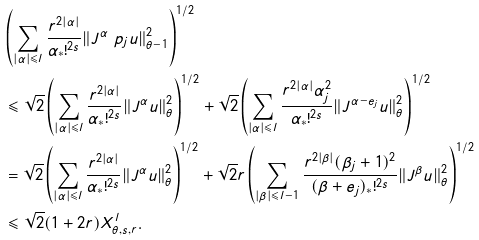<formula> <loc_0><loc_0><loc_500><loc_500>& \left ( \sum _ { | \alpha | \leqslant { l } } \frac { r ^ { 2 | \alpha | } } { \alpha _ { \ast } ! ^ { 2 s } } \| { J ^ { \alpha } \ p _ { j } u } \| _ { \theta - 1 } ^ { 2 } \right ) ^ { 1 / 2 } \\ & \leqslant \sqrt { 2 } \left ( \sum _ { | \alpha | \leqslant { l } } \frac { r ^ { 2 | \alpha | } } { \alpha _ { \ast } ! ^ { 2 s } } \| { J ^ { \alpha } } u \| _ { \theta } ^ { 2 } \right ) ^ { 1 / 2 } + \sqrt { 2 } \left ( \sum _ { | \alpha | \leqslant { l } } \frac { r ^ { 2 | \alpha | } \alpha _ { j } ^ { 2 } } { \alpha _ { \ast } ! ^ { 2 s } } \| { J ^ { \alpha - e _ { j } } u } \| _ { \theta } ^ { 2 } \right ) ^ { 1 / 2 } \\ & = \sqrt { 2 } \left ( \sum _ { | \alpha | \leqslant { l } } \frac { r ^ { 2 | \alpha | } } { \alpha _ { \ast } ! ^ { 2 s } } \| { J ^ { \alpha } } u \| _ { \theta } ^ { 2 } \right ) ^ { 1 / 2 } + \sqrt { 2 } r \left ( \sum _ { | \beta | \leqslant { l - 1 } } \frac { r ^ { 2 | \beta | } ( \beta _ { j } + 1 ) ^ { 2 } } { ( \beta + e _ { j } ) _ { \ast } ! ^ { 2 s } } \| { J ^ { \beta } u } \| _ { \theta } ^ { 2 } \right ) ^ { 1 / 2 } \\ & \leqslant \sqrt { 2 } ( 1 + 2 r ) X ^ { l } _ { \theta , s , r } .</formula> 